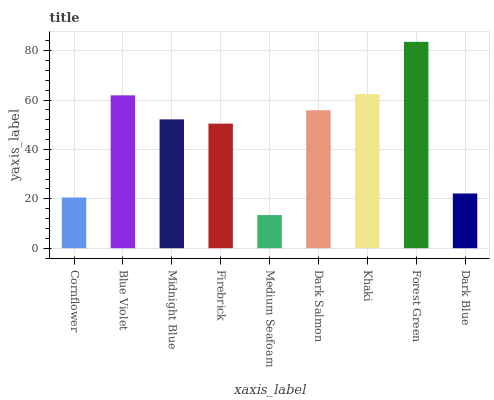Is Medium Seafoam the minimum?
Answer yes or no. Yes. Is Forest Green the maximum?
Answer yes or no. Yes. Is Blue Violet the minimum?
Answer yes or no. No. Is Blue Violet the maximum?
Answer yes or no. No. Is Blue Violet greater than Cornflower?
Answer yes or no. Yes. Is Cornflower less than Blue Violet?
Answer yes or no. Yes. Is Cornflower greater than Blue Violet?
Answer yes or no. No. Is Blue Violet less than Cornflower?
Answer yes or no. No. Is Midnight Blue the high median?
Answer yes or no. Yes. Is Midnight Blue the low median?
Answer yes or no. Yes. Is Blue Violet the high median?
Answer yes or no. No. Is Medium Seafoam the low median?
Answer yes or no. No. 